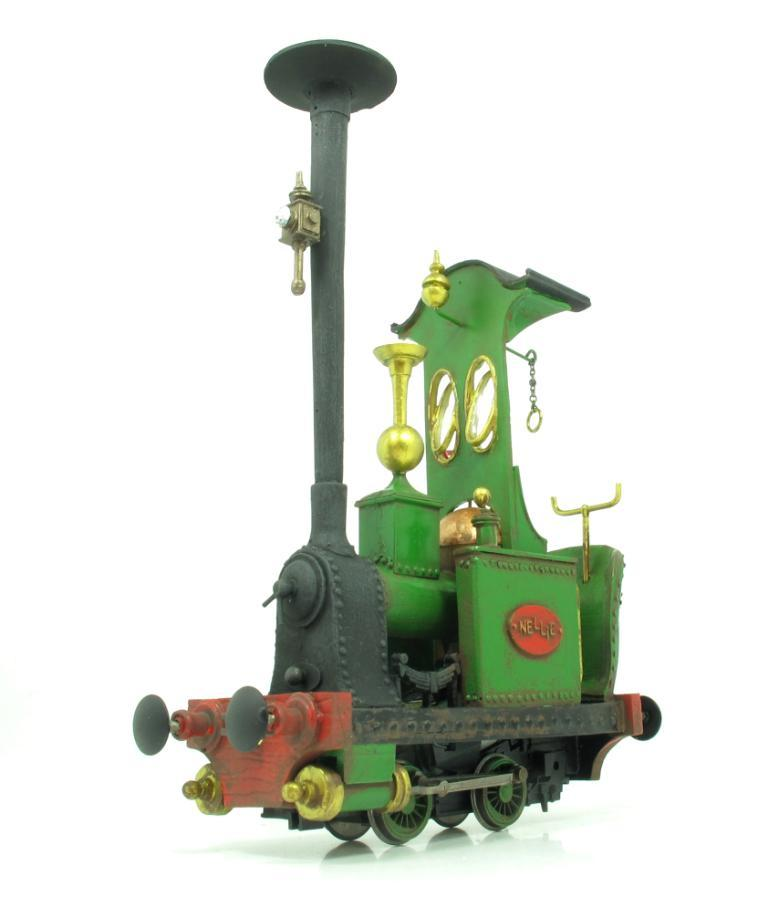What is placed on the floor in the image? There is a toy locomotive engine on the floor. Can you describe the type of toy that is on the floor? It is a toy locomotive engine. What holiday is being celebrated in the image? There is no indication of a holiday being celebrated in the image. What type of selection process is being depicted in the image? There is no selection process depicted in the image; it features a toy locomotive engine on the floor. 